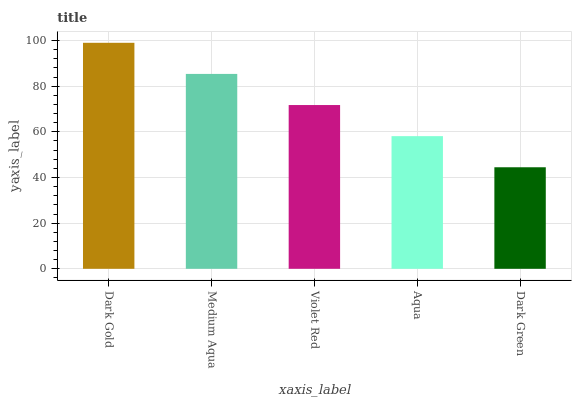Is Dark Green the minimum?
Answer yes or no. Yes. Is Dark Gold the maximum?
Answer yes or no. Yes. Is Medium Aqua the minimum?
Answer yes or no. No. Is Medium Aqua the maximum?
Answer yes or no. No. Is Dark Gold greater than Medium Aqua?
Answer yes or no. Yes. Is Medium Aqua less than Dark Gold?
Answer yes or no. Yes. Is Medium Aqua greater than Dark Gold?
Answer yes or no. No. Is Dark Gold less than Medium Aqua?
Answer yes or no. No. Is Violet Red the high median?
Answer yes or no. Yes. Is Violet Red the low median?
Answer yes or no. Yes. Is Medium Aqua the high median?
Answer yes or no. No. Is Aqua the low median?
Answer yes or no. No. 